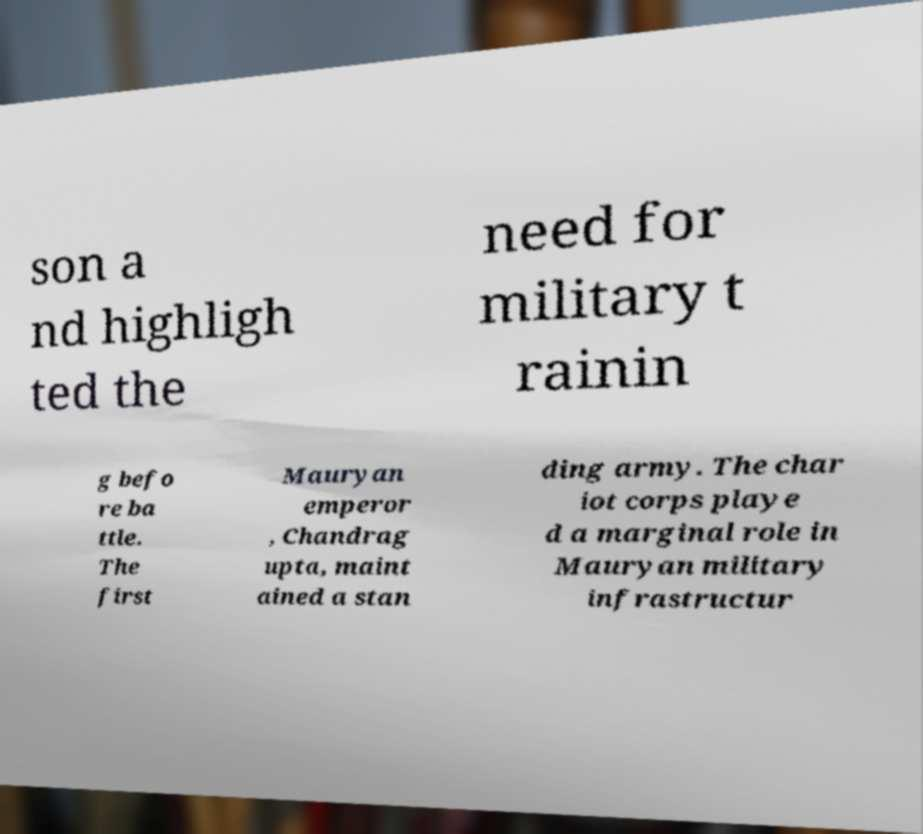I need the written content from this picture converted into text. Can you do that? son a nd highligh ted the need for military t rainin g befo re ba ttle. The first Mauryan emperor , Chandrag upta, maint ained a stan ding army. The char iot corps playe d a marginal role in Mauryan military infrastructur 